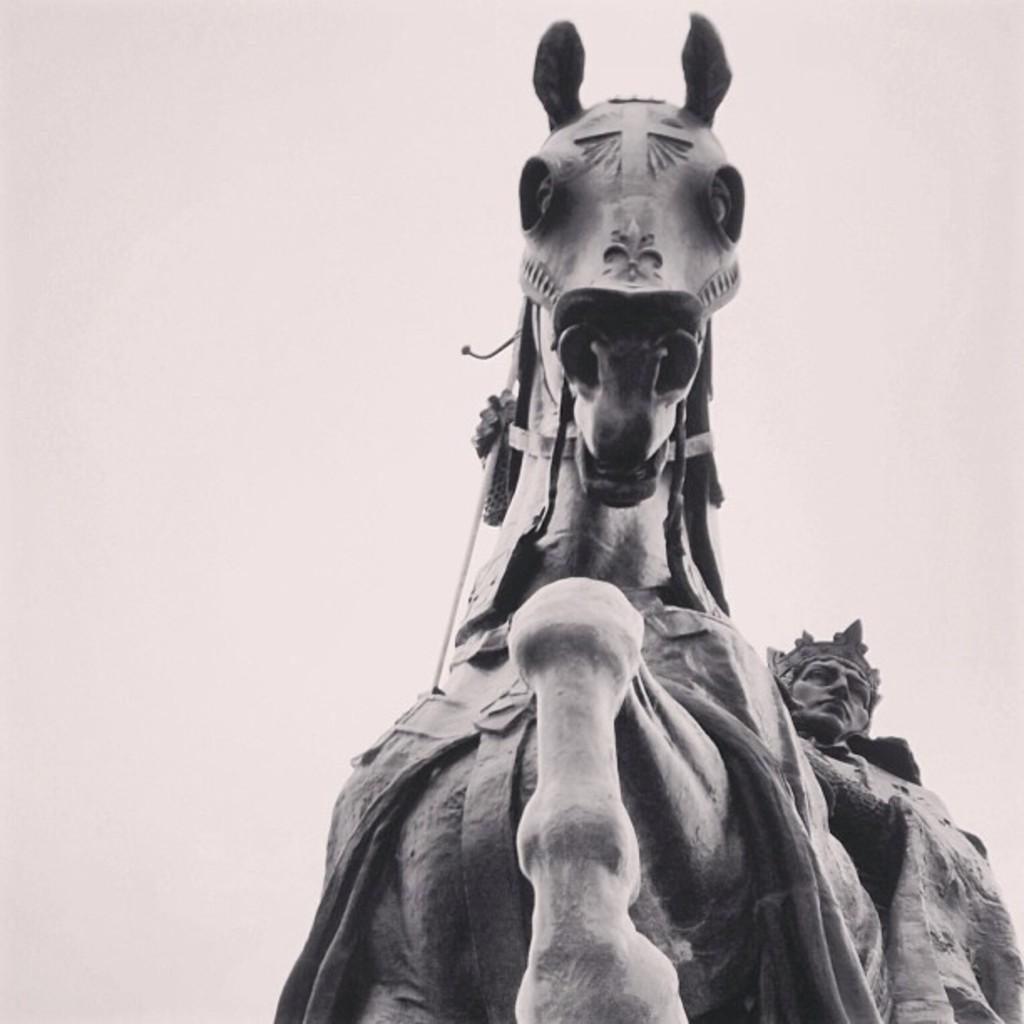What is the color scheme of the image? The picture is black and white. What is the main subject of the image? There is a person sitting on a horse in the image. What type of bone can be seen in the image? There is no bone present in the image; it features a person sitting on a horse. How many sides does the horse have in the image? The horse has four sides, as it is a living creature with a body and four legs. However, the image is in two dimensions, so it appears as a flat representation of the horse. 